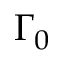<formula> <loc_0><loc_0><loc_500><loc_500>\Gamma _ { 0 }</formula> 